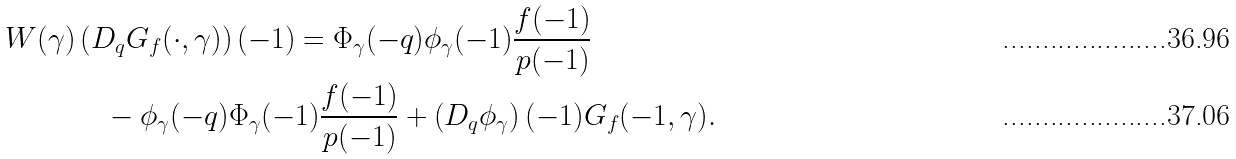Convert formula to latex. <formula><loc_0><loc_0><loc_500><loc_500>W ( \gamma ) & \left ( D _ { q } G _ { f } ( \cdot , \gamma ) \right ) ( - 1 ) = \Phi _ { \gamma } ( - q ) \phi _ { \gamma } ( - 1 ) \frac { f ( - 1 ) } { p ( - 1 ) } \\ & \quad - \phi _ { \gamma } ( - q ) \Phi _ { \gamma } ( - 1 ) \frac { f ( - 1 ) } { p ( - 1 ) } + \left ( D _ { q } \phi _ { \gamma } \right ) ( - 1 ) G _ { f } ( - 1 , \gamma ) .</formula> 